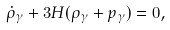Convert formula to latex. <formula><loc_0><loc_0><loc_500><loc_500>\dot { \rho } _ { \gamma } + 3 H ( \rho _ { \gamma } + p _ { \gamma } ) = 0 ,</formula> 